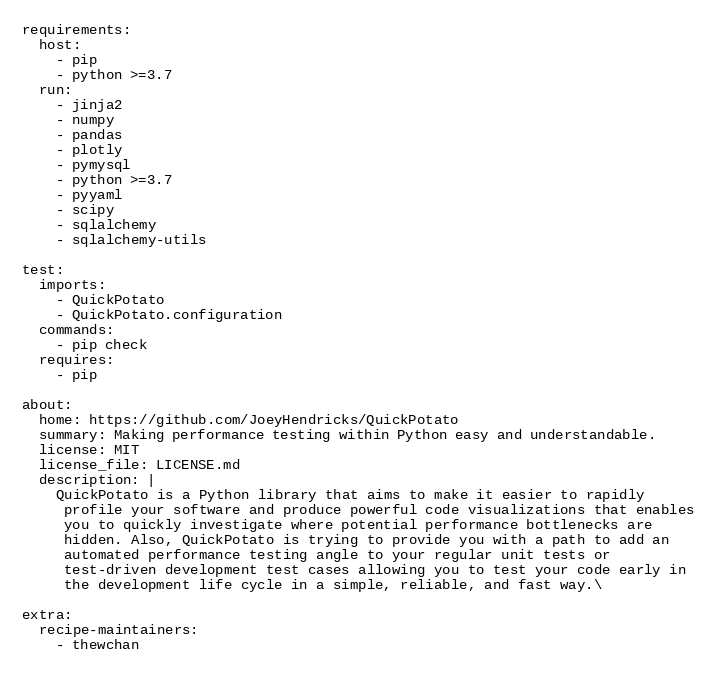<code> <loc_0><loc_0><loc_500><loc_500><_YAML_>requirements:
  host:
    - pip
    - python >=3.7
  run:
    - jinja2
    - numpy
    - pandas
    - plotly
    - pymysql
    - python >=3.7
    - pyyaml
    - scipy
    - sqlalchemy
    - sqlalchemy-utils

test:
  imports:
    - QuickPotato
    - QuickPotato.configuration
  commands:
    - pip check
  requires:
    - pip

about:
  home: https://github.com/JoeyHendricks/QuickPotato
  summary: Making performance testing within Python easy and understandable.
  license: MIT
  license_file: LICENSE.md
  description: |
    QuickPotato is a Python library that aims to make it easier to rapidly
     profile your software and produce powerful code visualizations that enables
     you to quickly investigate where potential performance bottlenecks are
     hidden. Also, QuickPotato is trying to provide you with a path to add an
     automated performance testing angle to your regular unit tests or
     test-driven development test cases allowing you to test your code early in
     the development life cycle in a simple, reliable, and fast way.\

extra:
  recipe-maintainers:
    - thewchan
</code> 